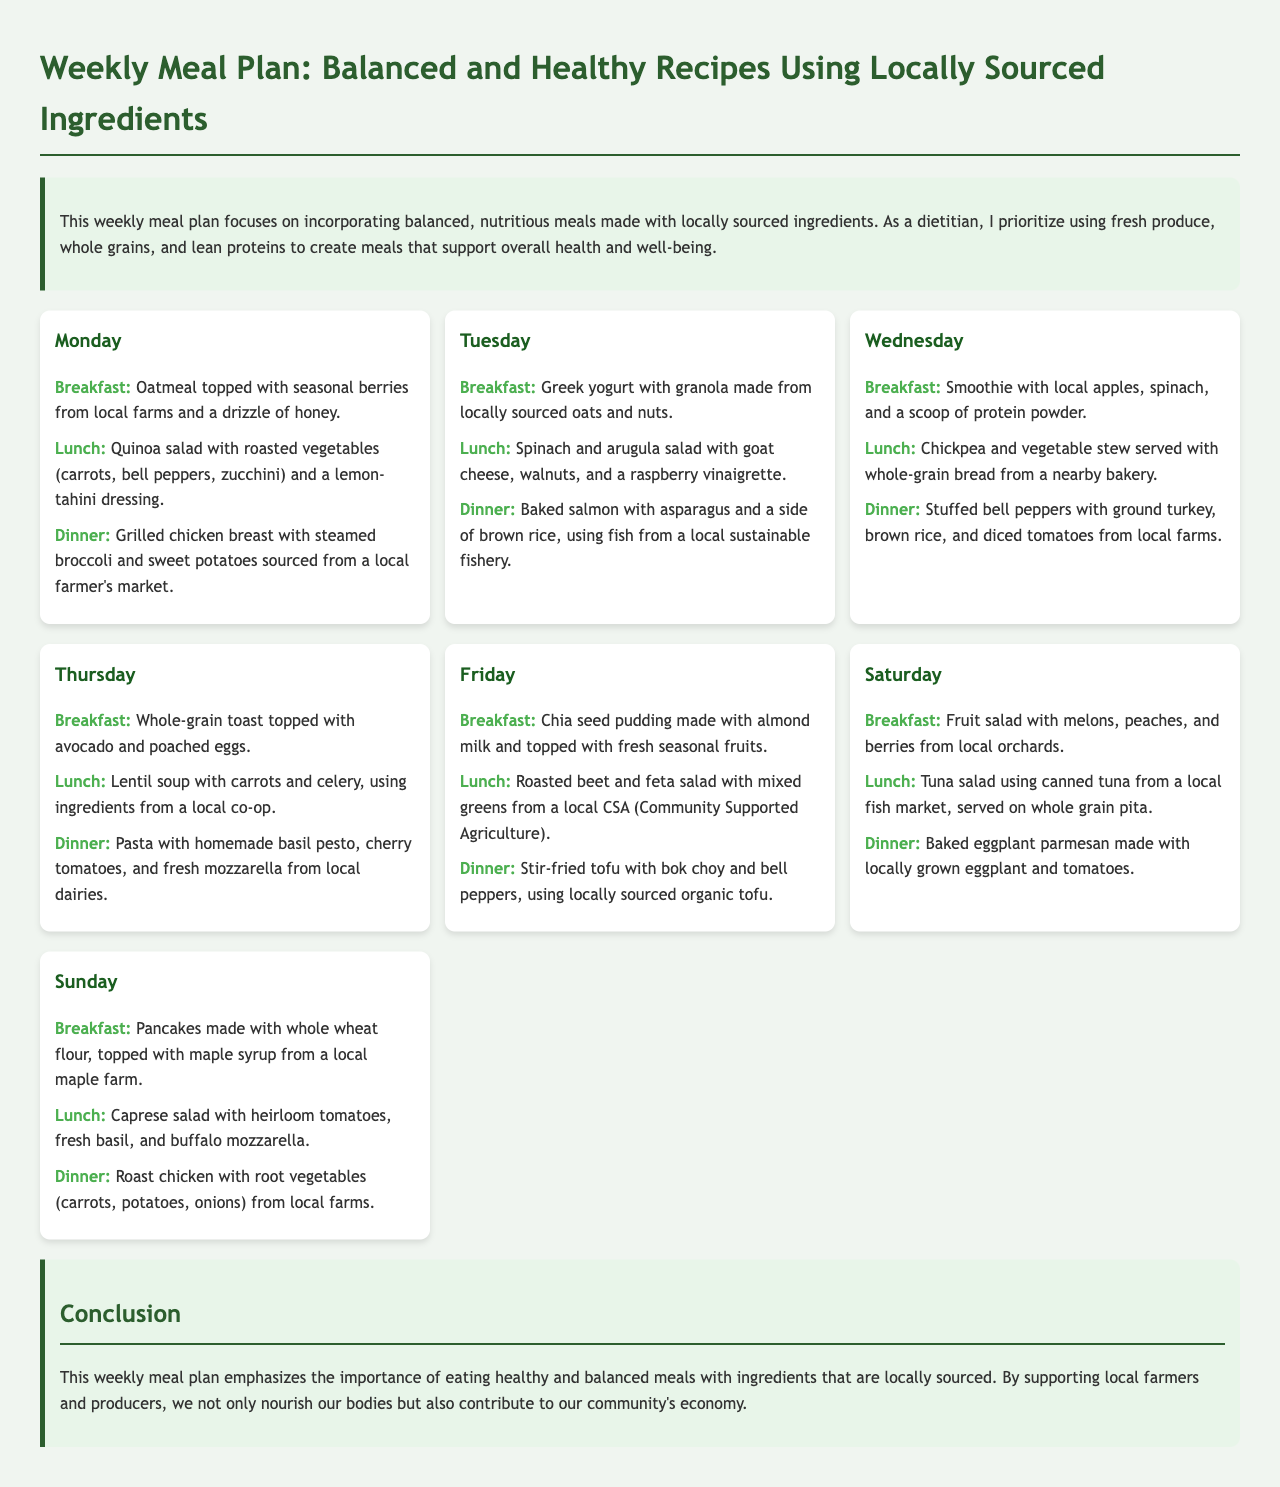What is the title of the meal plan? The title provides the main subject of the document, which is presented at the top.
Answer: Weekly Meal Plan: Local & Healthy Which day features a quinoa salad for lunch? The document lists meals for each day, and this meal appears on a specific day.
Answer: Monday What type of fish is used in Tuesday's dinner? The document specifies the source and type of fish for that meal.
Answer: Salmon What is the main ingredient in Wednesday's breakfast? The breakfast is categorized by its primary ingredient, as stated in the document.
Answer: Apples What kind of soup is served for lunch on Thursday? The document identifies the type of soup included in that day's menu.
Answer: Lentil soup How many meals are listed for each day? Each day has the same number of meals, contributing to the structure of the document.
Answer: Three What is emphasized in the conclusion of the meal plan? The conclusion summarizes the main focus and importance of the meal plan presented.
Answer: Importance of eating healthy What type of dressing is used in Monday's lunch? The dressing for that specific meal is stated clearly in the document.
Answer: Lemon-tahini dressing 